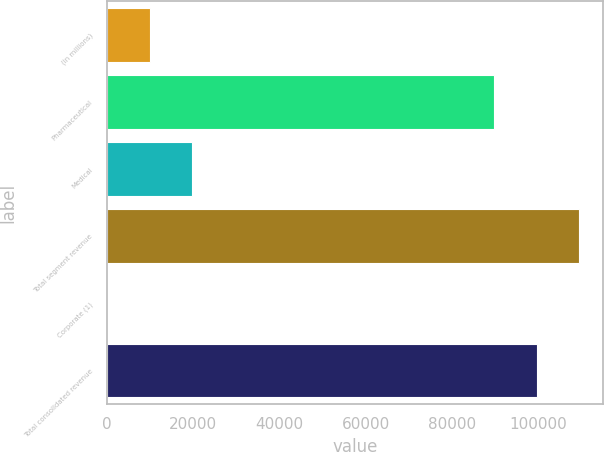<chart> <loc_0><loc_0><loc_500><loc_500><bar_chart><fcel>(in millions)<fcel>Pharmaceutical<fcel>Medical<fcel>Total segment revenue<fcel>Corporate (1)<fcel>Total consolidated revenue<nl><fcel>9887.3<fcel>89790<fcel>19737.6<fcel>109491<fcel>37<fcel>99640.3<nl></chart> 